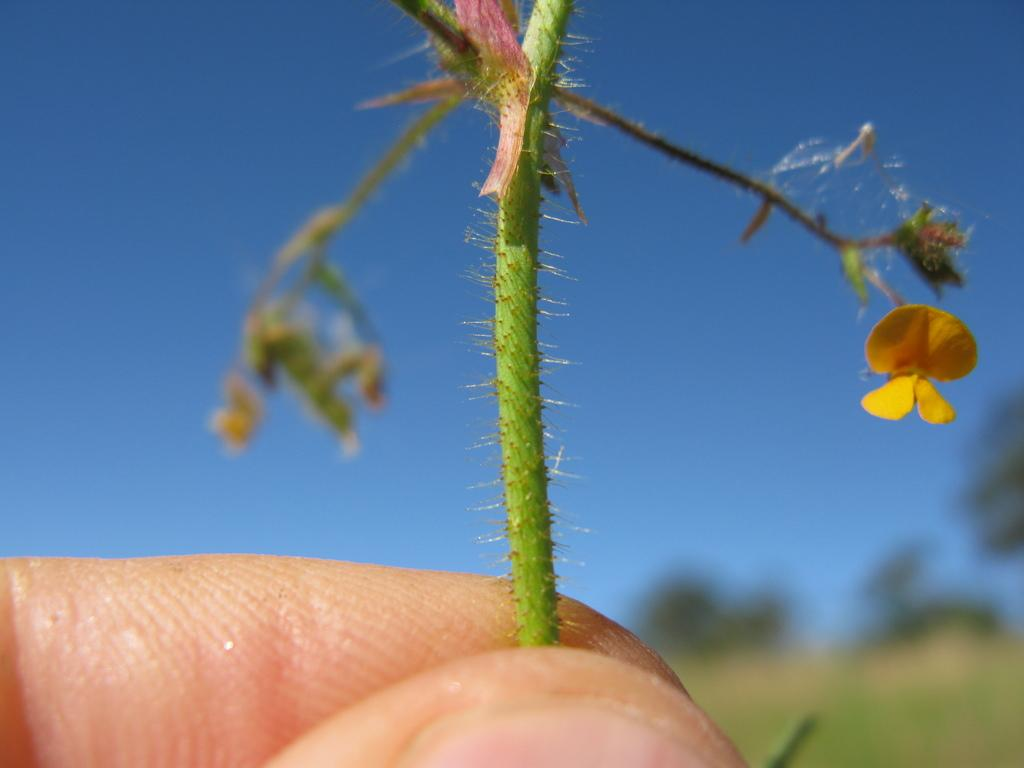What is being held in the person's hand in the image? There is a plant in the fingers of a person's hand in the image. What can be observed about the background of the image? The background of the image is blurred. What natural elements can be seen in the background of the image? The sky, trees, and grass are visible in the background of the image. What type of grain is being harvested by the person in the image? There is no grain present in the image; it features a person holding a plant in their hand. Can you hear the drum being played in the background of the image? There is no drum or sound present in the image; it is a still photograph. 